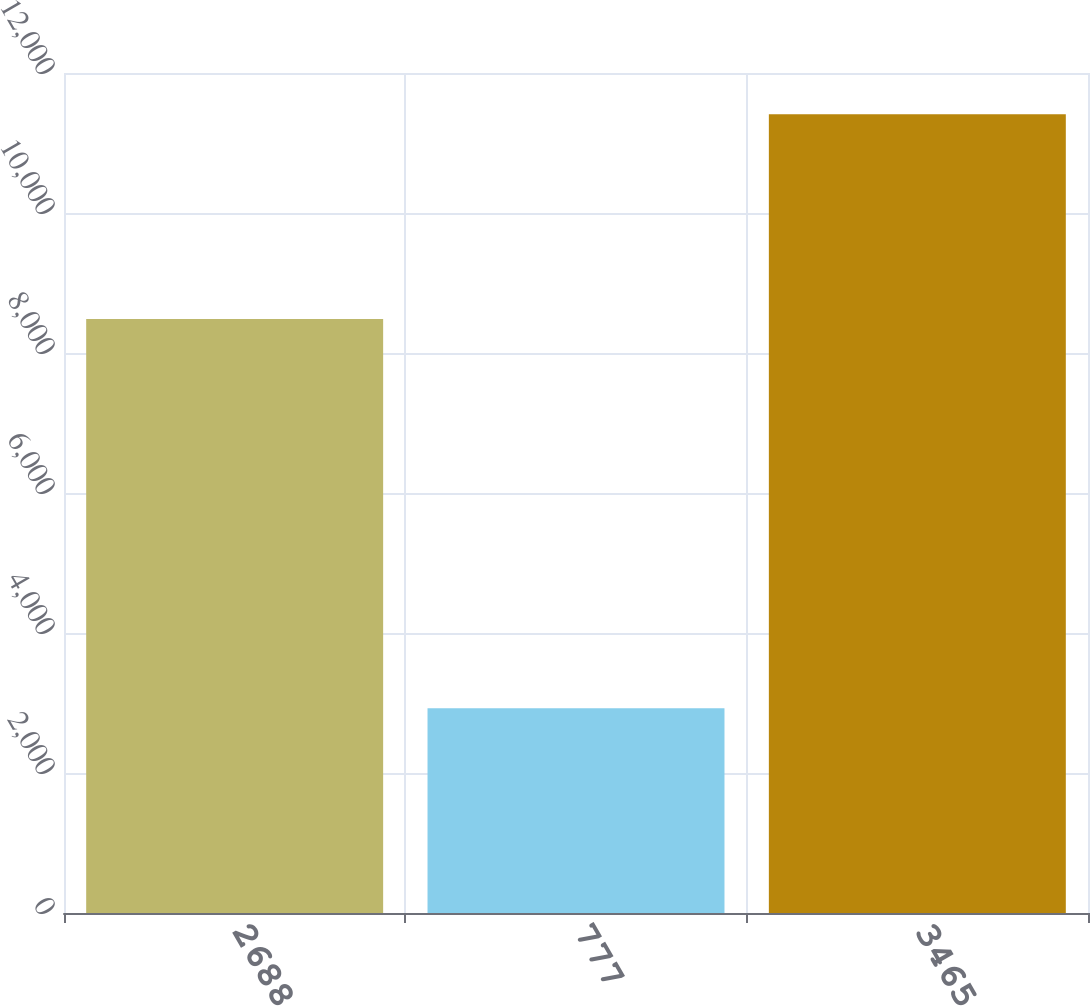<chart> <loc_0><loc_0><loc_500><loc_500><bar_chart><fcel>2688<fcel>777<fcel>3465<nl><fcel>8485<fcel>2924<fcel>11409<nl></chart> 